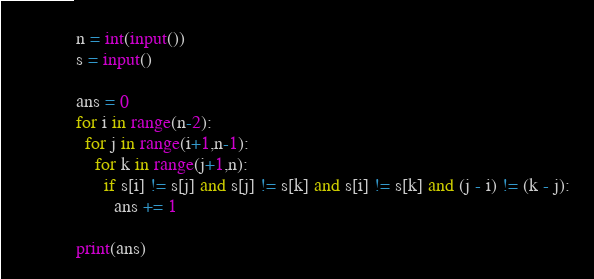Convert code to text. <code><loc_0><loc_0><loc_500><loc_500><_Python_>n = int(input())
s = input()

ans = 0
for i in range(n-2):
  for j in range(i+1,n-1):
    for k in range(j+1,n):
      if s[i] != s[j] and s[j] != s[k] and s[i] != s[k] and (j - i) != (k - j):
        ans += 1

print(ans)</code> 